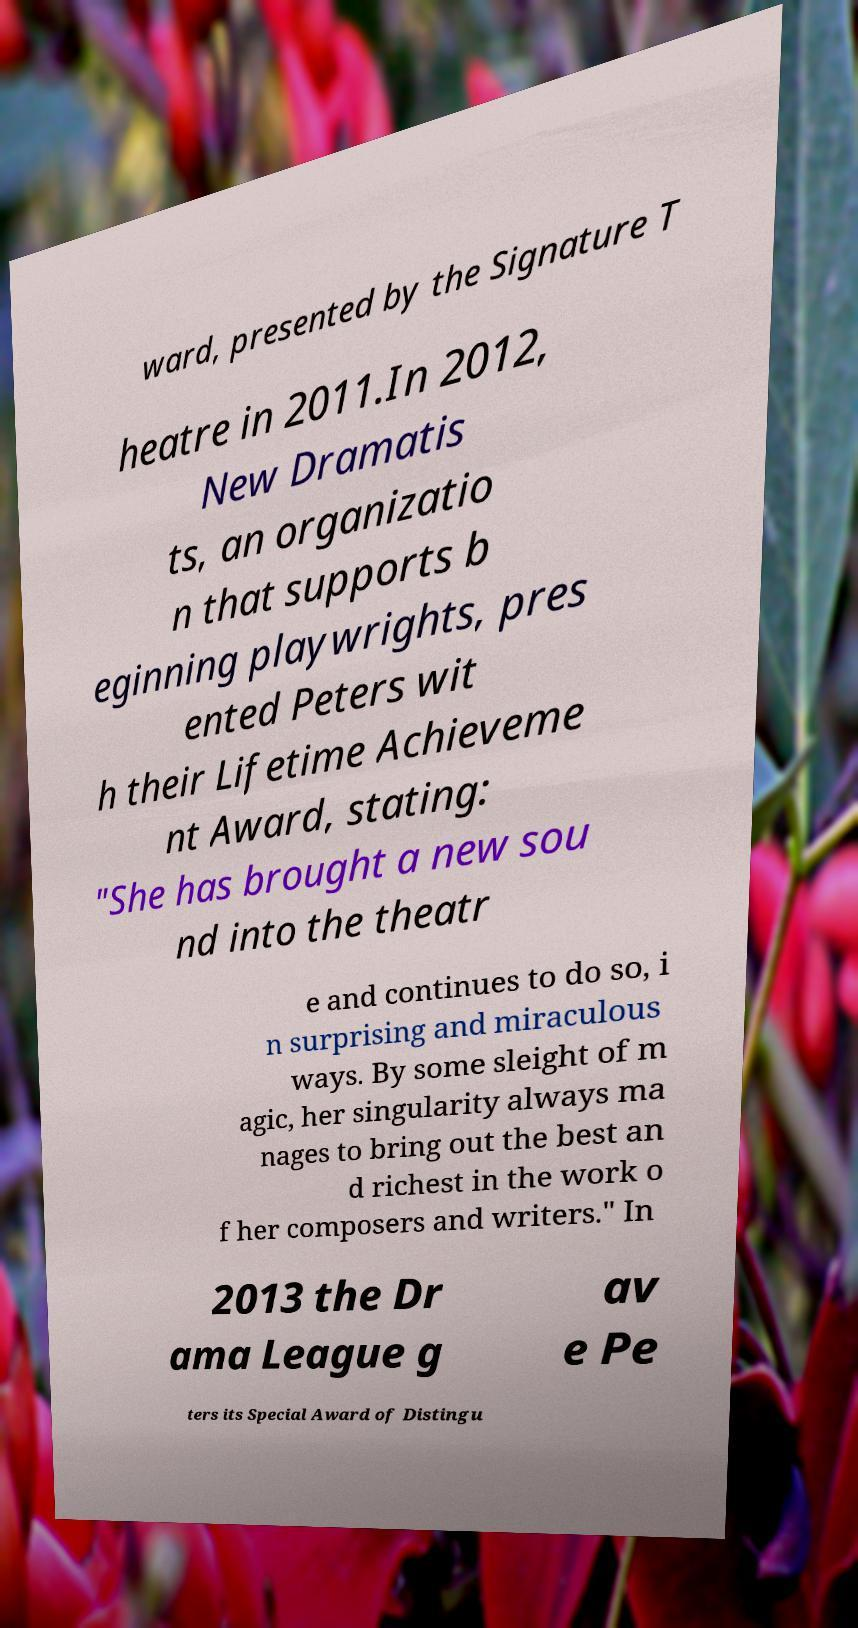For documentation purposes, I need the text within this image transcribed. Could you provide that? ward, presented by the Signature T heatre in 2011.In 2012, New Dramatis ts, an organizatio n that supports b eginning playwrights, pres ented Peters wit h their Lifetime Achieveme nt Award, stating: "She has brought a new sou nd into the theatr e and continues to do so, i n surprising and miraculous ways. By some sleight of m agic, her singularity always ma nages to bring out the best an d richest in the work o f her composers and writers." In 2013 the Dr ama League g av e Pe ters its Special Award of Distingu 